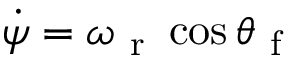<formula> <loc_0><loc_0><loc_500><loc_500>\dot { \psi } = \omega _ { r } \cos \theta _ { f }</formula> 